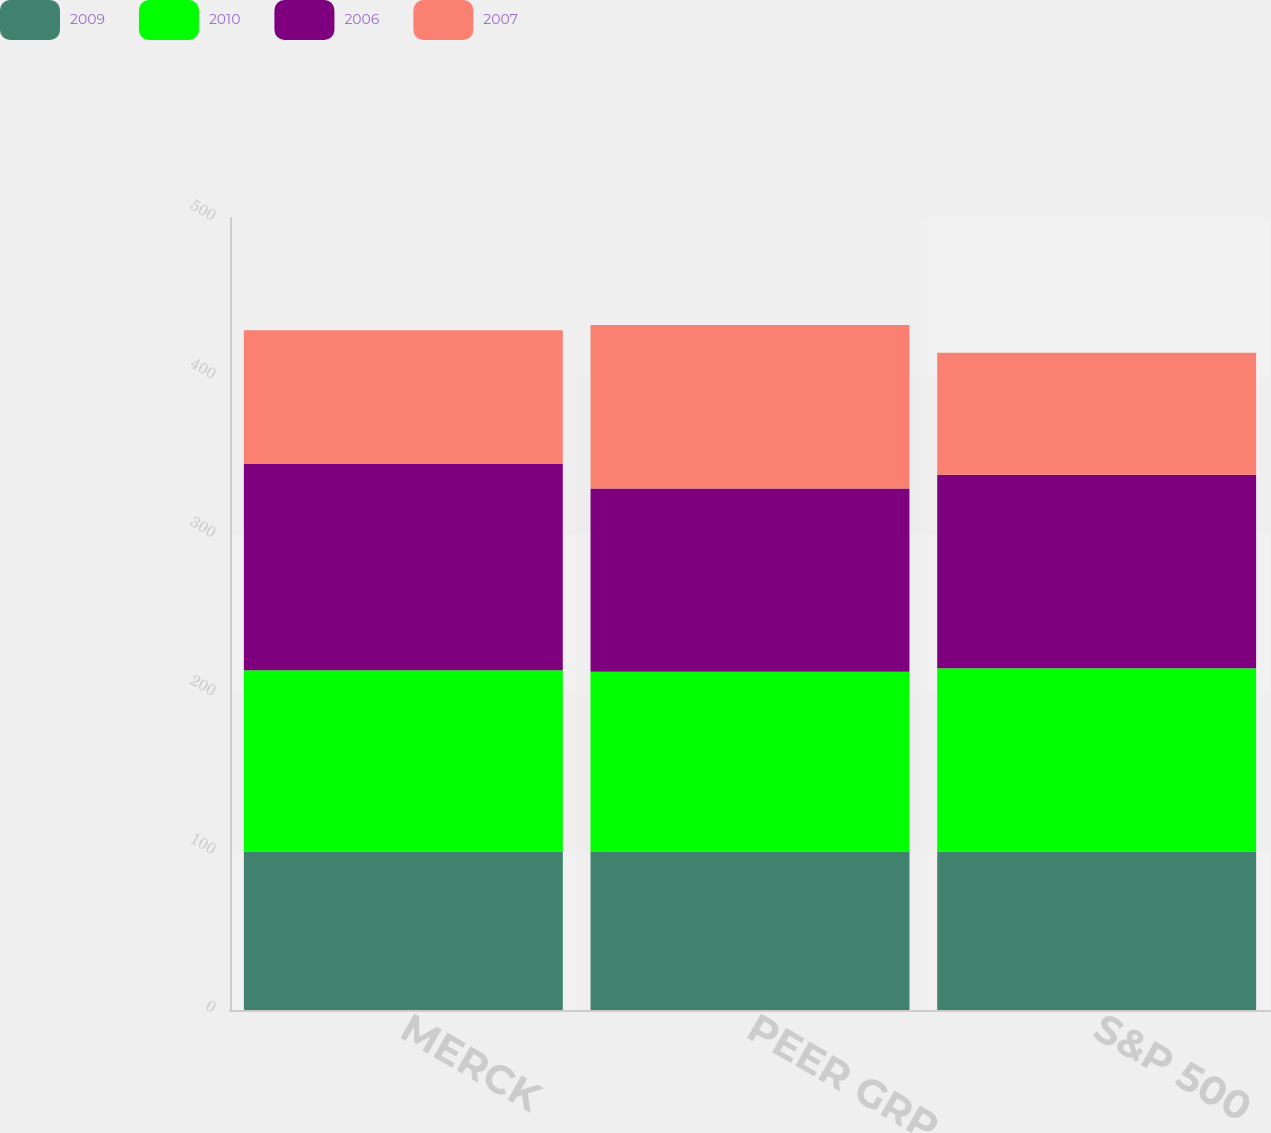Convert chart. <chart><loc_0><loc_0><loc_500><loc_500><stacked_bar_chart><ecel><fcel>MERCK<fcel>PEER GRP<fcel>S&P 500<nl><fcel>2009<fcel>100<fcel>100<fcel>100<nl><fcel>2010<fcel>114.44<fcel>113.53<fcel>115.78<nl><fcel>2006<fcel>130.18<fcel>115.73<fcel>122.14<nl><fcel>2007<fcel>84.49<fcel>103.19<fcel>76.96<nl></chart> 